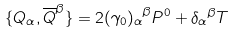Convert formula to latex. <formula><loc_0><loc_0><loc_500><loc_500>\{ Q _ { \alpha } , \overline { Q } ^ { \beta } \} = 2 { ( \gamma _ { 0 } ) _ { \alpha } } ^ { \beta } P ^ { 0 } + { \delta _ { \alpha } } ^ { \beta } T</formula> 